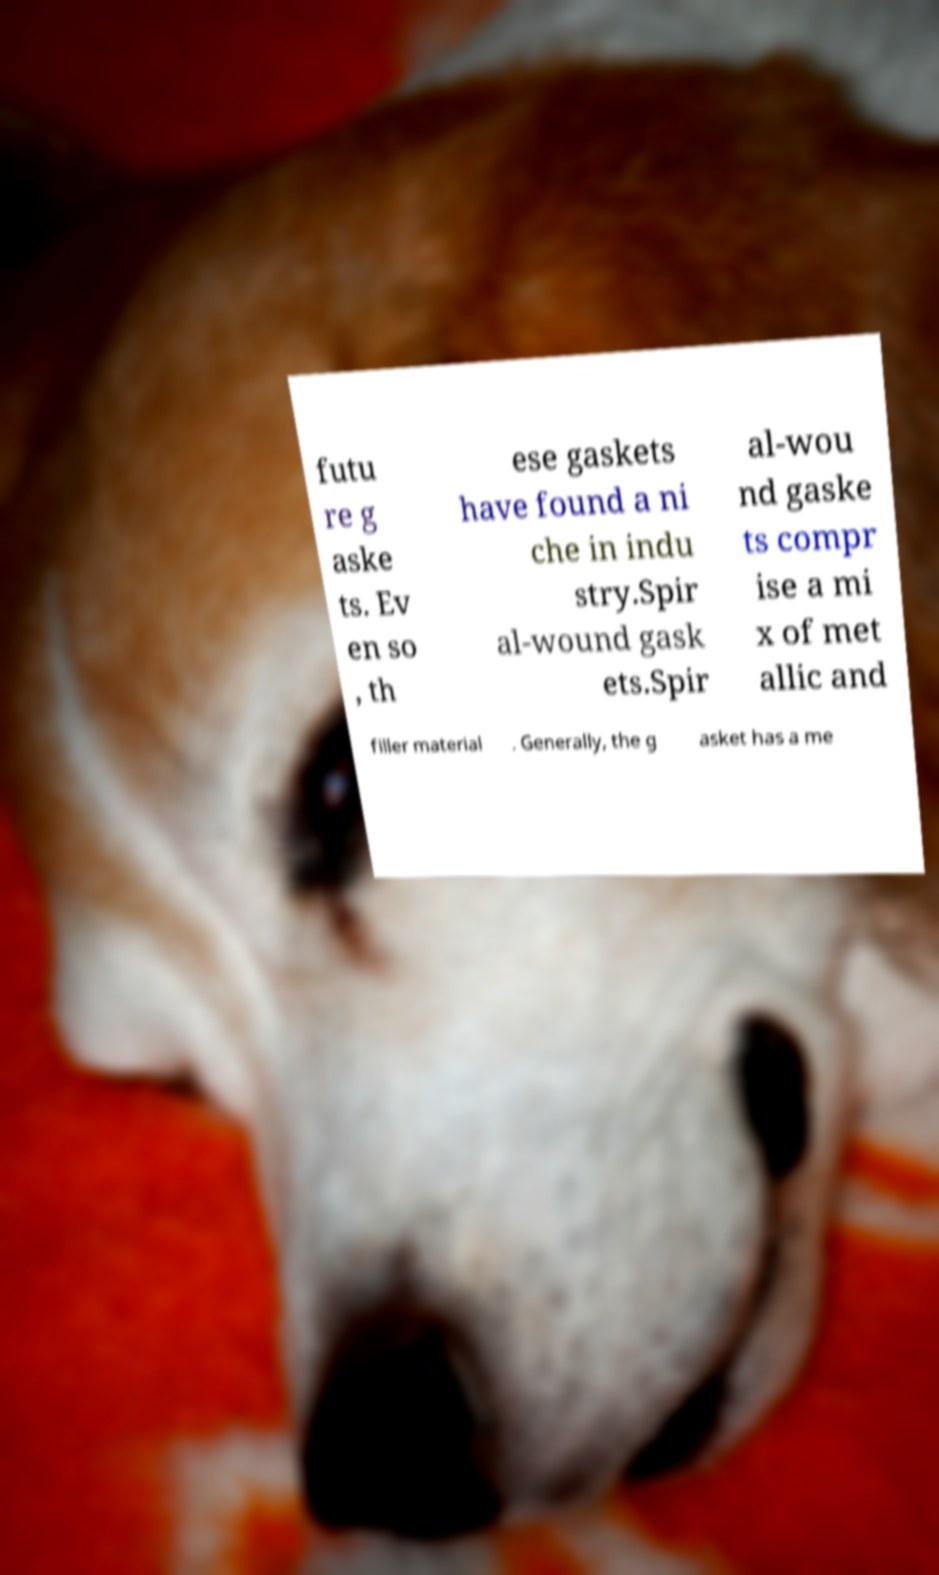There's text embedded in this image that I need extracted. Can you transcribe it verbatim? futu re g aske ts. Ev en so , th ese gaskets have found a ni che in indu stry.Spir al-wound gask ets.Spir al-wou nd gaske ts compr ise a mi x of met allic and filler material . Generally, the g asket has a me 